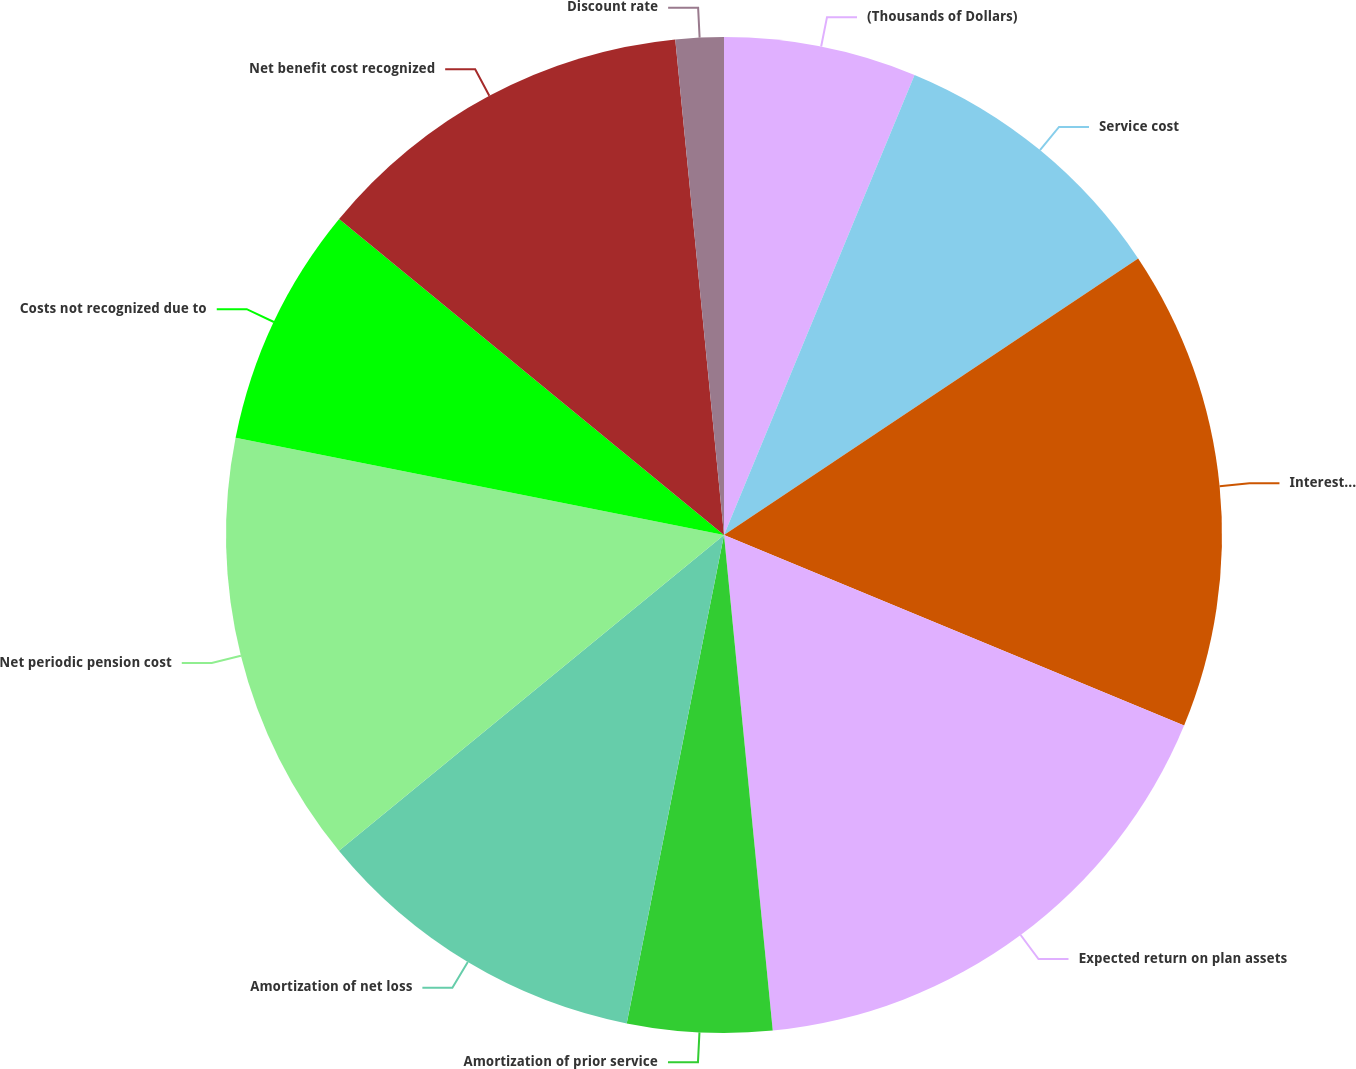Convert chart to OTSL. <chart><loc_0><loc_0><loc_500><loc_500><pie_chart><fcel>(Thousands of Dollars)<fcel>Service cost<fcel>Interest cost<fcel>Expected return on plan assets<fcel>Amortization of prior service<fcel>Amortization of net loss<fcel>Net periodic pension cost<fcel>Costs not recognized due to<fcel>Net benefit cost recognized<fcel>Discount rate<nl><fcel>6.25%<fcel>9.38%<fcel>15.62%<fcel>17.19%<fcel>4.69%<fcel>10.94%<fcel>14.06%<fcel>7.81%<fcel>12.5%<fcel>1.56%<nl></chart> 